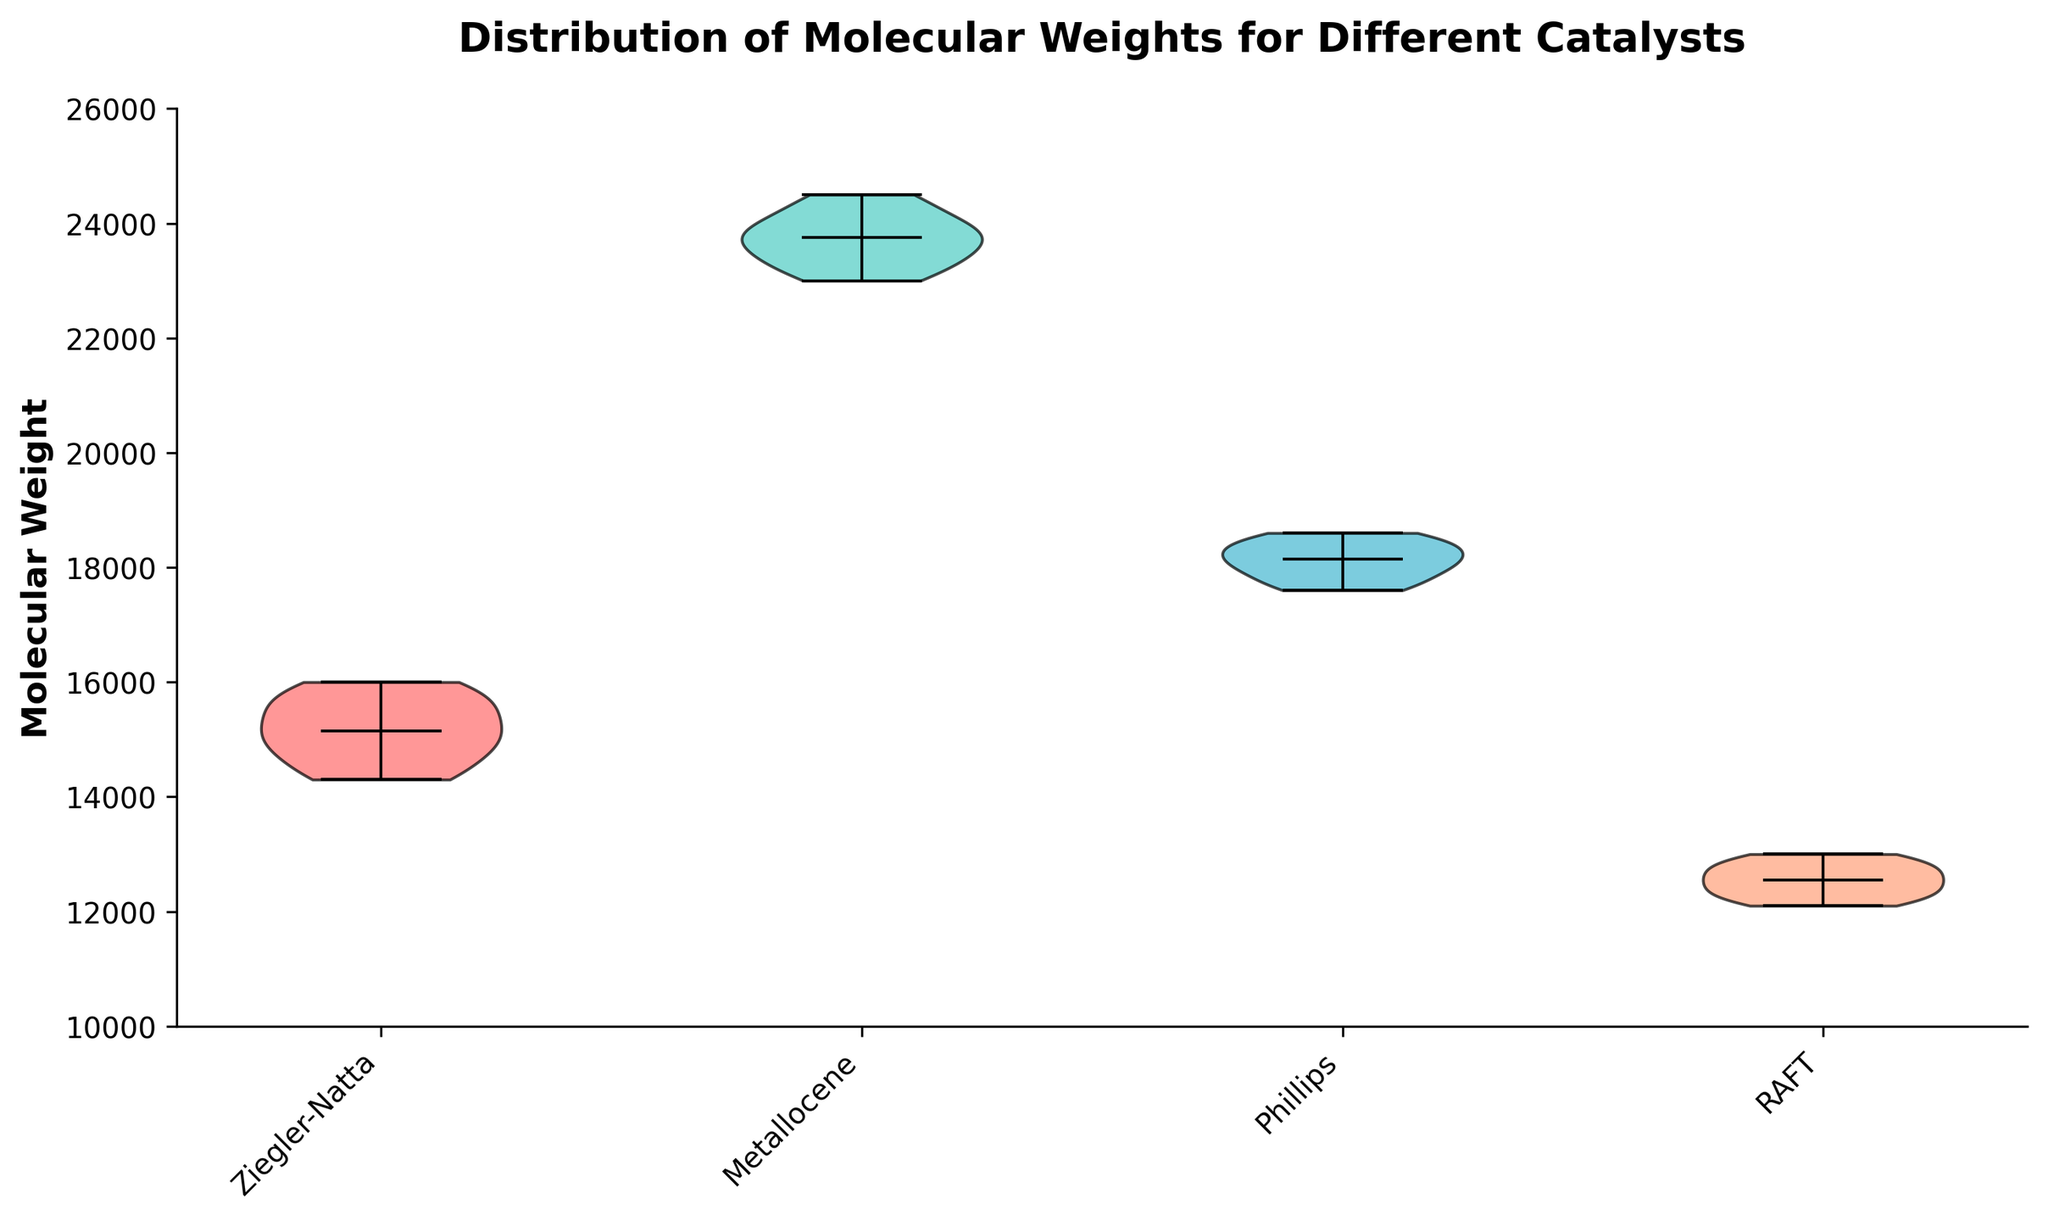Which catalyst has the highest median molecular weight? The median values are shown with horizontal lines in the middle of each violin plot. Ziegler-Natta has the lowest, RAFT is higher, Phillips is even higher, but Metallocene is the highest.
Answer: Metallocene Which catalyst has the lowest median molecular weight? The lowest median can be identified by locating the shortest horizontal line in the plots. Ziegler-Natta's median line is the shortest.
Answer: Ziegler-Natta What is the range of molecular weights for the Phillips catalyst? Look at the vertical extent of the Phillips violin plot from the lowest point to the highest point. The range spans from 17600 to 18600.
Answer: 17600 to 18600 How does the spread of molecular weights for RAFT compare to that of Metallocene? The spread is given by the width of the violin plots. RAFT's plot is narrower indicating less variability, whereas Metallocene's plot is wider implying more variability.
Answer: RAFT has less variability compared to Metallocene Which catalyst shows the widest distribution of molecular weights? The catalyst with the widest violin plot represents the greatest spread. Visually, Metallocene's plot is the widest.
Answer: Metallocene Which catalysts have interquartile ranges that do not overlap? Interquartile ranges are represented by the central thick areas of the violin plots. Observing these areas, RAFT and Metallocene do not overlap with each other.
Answer: RAFT and Metallocene What is the approximate median molecular weight for Ziegler-Natta? The median is shown as a horizontal line in the middle of the plot; for Ziegler-Natta, it appears around 15000.
Answer: 15000 Which catalyst has the most symmetrical distribution of molecular weight? Symmetry can be observed by checking if the violin plots are identical on both sides of the median line. Phillips appears the most symmetrical.
Answer: Phillips How many catalysts were used in the synthesis? The number of distinct violin plots corresponds to the number of catalysts. There are four violin plots.
Answer: Four Do all catalysts have at least one molecular weight value above 20000? Examine the upper portion of each violin plot to see if it extends above 20000. Only Metallocene's plot does so.
Answer: No 